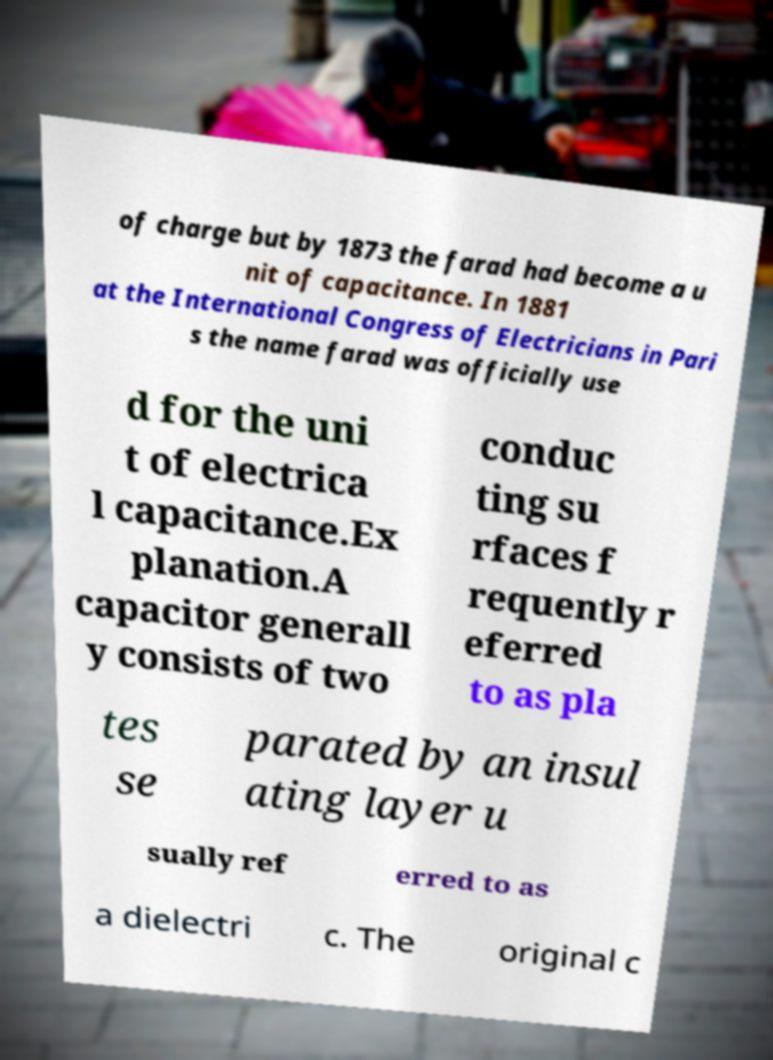Please read and relay the text visible in this image. What does it say? of charge but by 1873 the farad had become a u nit of capacitance. In 1881 at the International Congress of Electricians in Pari s the name farad was officially use d for the uni t of electrica l capacitance.Ex planation.A capacitor generall y consists of two conduc ting su rfaces f requently r eferred to as pla tes se parated by an insul ating layer u sually ref erred to as a dielectri c. The original c 